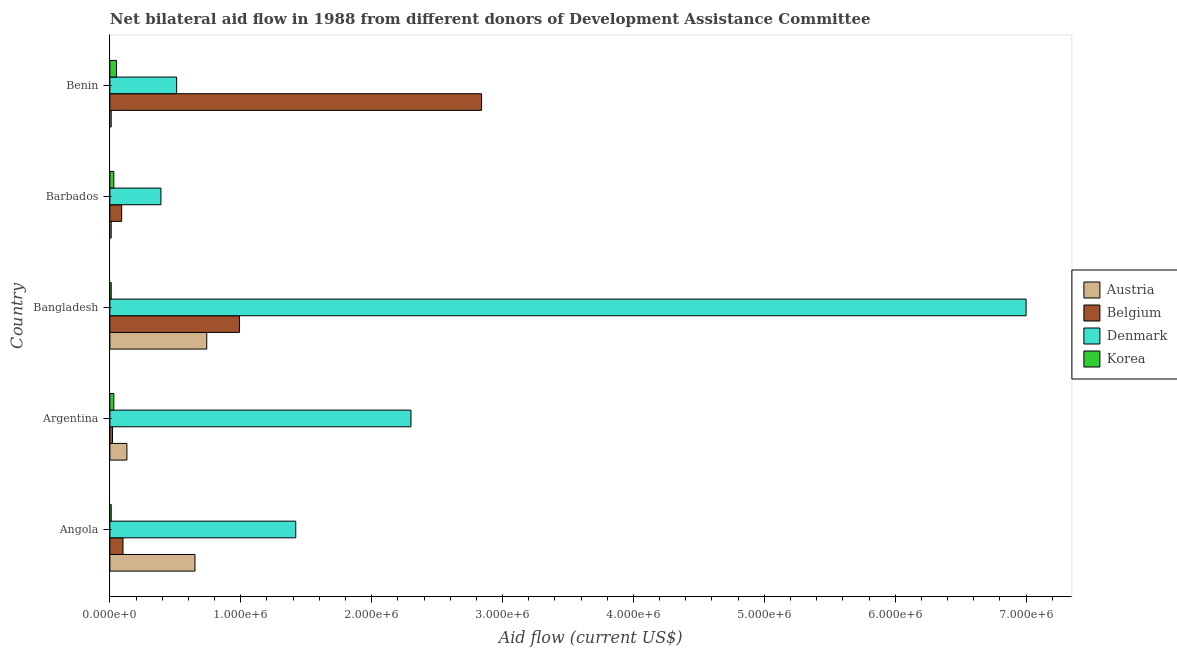Are the number of bars per tick equal to the number of legend labels?
Give a very brief answer. Yes. How many bars are there on the 5th tick from the top?
Give a very brief answer. 4. What is the label of the 2nd group of bars from the top?
Give a very brief answer. Barbados. What is the amount of aid given by korea in Bangladesh?
Offer a very short reply. 10000. Across all countries, what is the maximum amount of aid given by austria?
Your answer should be very brief. 7.40e+05. Across all countries, what is the minimum amount of aid given by austria?
Make the answer very short. 10000. In which country was the amount of aid given by denmark minimum?
Your answer should be very brief. Barbados. What is the total amount of aid given by denmark in the graph?
Ensure brevity in your answer.  1.16e+07. What is the difference between the amount of aid given by korea in Bangladesh and that in Barbados?
Offer a very short reply. -2.00e+04. What is the average amount of aid given by korea per country?
Ensure brevity in your answer.  2.60e+04. What is the difference between the amount of aid given by korea and amount of aid given by denmark in Angola?
Make the answer very short. -1.41e+06. In how many countries, is the amount of aid given by austria greater than 5600000 US$?
Make the answer very short. 0. What is the ratio of the amount of aid given by denmark in Angola to that in Argentina?
Offer a terse response. 0.62. What is the difference between the highest and the lowest amount of aid given by denmark?
Make the answer very short. 6.61e+06. Is the sum of the amount of aid given by austria in Argentina and Barbados greater than the maximum amount of aid given by korea across all countries?
Keep it short and to the point. Yes. What does the 1st bar from the top in Barbados represents?
Your answer should be very brief. Korea. What does the 3rd bar from the bottom in Benin represents?
Offer a terse response. Denmark. Are the values on the major ticks of X-axis written in scientific E-notation?
Your answer should be compact. Yes. Does the graph contain any zero values?
Offer a terse response. No. How many legend labels are there?
Offer a terse response. 4. What is the title of the graph?
Provide a succinct answer. Net bilateral aid flow in 1988 from different donors of Development Assistance Committee. What is the label or title of the X-axis?
Your response must be concise. Aid flow (current US$). What is the Aid flow (current US$) in Austria in Angola?
Your answer should be very brief. 6.50e+05. What is the Aid flow (current US$) in Denmark in Angola?
Ensure brevity in your answer.  1.42e+06. What is the Aid flow (current US$) in Denmark in Argentina?
Provide a succinct answer. 2.30e+06. What is the Aid flow (current US$) in Austria in Bangladesh?
Provide a succinct answer. 7.40e+05. What is the Aid flow (current US$) of Belgium in Bangladesh?
Your answer should be very brief. 9.90e+05. What is the Aid flow (current US$) of Belgium in Barbados?
Make the answer very short. 9.00e+04. What is the Aid flow (current US$) of Austria in Benin?
Your answer should be compact. 10000. What is the Aid flow (current US$) of Belgium in Benin?
Provide a short and direct response. 2.84e+06. What is the Aid flow (current US$) of Denmark in Benin?
Provide a succinct answer. 5.10e+05. Across all countries, what is the maximum Aid flow (current US$) of Austria?
Your response must be concise. 7.40e+05. Across all countries, what is the maximum Aid flow (current US$) in Belgium?
Your response must be concise. 2.84e+06. Across all countries, what is the minimum Aid flow (current US$) of Belgium?
Offer a terse response. 2.00e+04. Across all countries, what is the minimum Aid flow (current US$) in Denmark?
Offer a very short reply. 3.90e+05. What is the total Aid flow (current US$) of Austria in the graph?
Provide a short and direct response. 1.54e+06. What is the total Aid flow (current US$) in Belgium in the graph?
Ensure brevity in your answer.  4.04e+06. What is the total Aid flow (current US$) in Denmark in the graph?
Keep it short and to the point. 1.16e+07. What is the difference between the Aid flow (current US$) of Austria in Angola and that in Argentina?
Ensure brevity in your answer.  5.20e+05. What is the difference between the Aid flow (current US$) of Denmark in Angola and that in Argentina?
Make the answer very short. -8.80e+05. What is the difference between the Aid flow (current US$) of Korea in Angola and that in Argentina?
Your response must be concise. -2.00e+04. What is the difference between the Aid flow (current US$) in Austria in Angola and that in Bangladesh?
Your response must be concise. -9.00e+04. What is the difference between the Aid flow (current US$) in Belgium in Angola and that in Bangladesh?
Keep it short and to the point. -8.90e+05. What is the difference between the Aid flow (current US$) of Denmark in Angola and that in Bangladesh?
Offer a very short reply. -5.58e+06. What is the difference between the Aid flow (current US$) in Korea in Angola and that in Bangladesh?
Offer a very short reply. 0. What is the difference between the Aid flow (current US$) in Austria in Angola and that in Barbados?
Your answer should be compact. 6.40e+05. What is the difference between the Aid flow (current US$) of Denmark in Angola and that in Barbados?
Your answer should be very brief. 1.03e+06. What is the difference between the Aid flow (current US$) in Austria in Angola and that in Benin?
Give a very brief answer. 6.40e+05. What is the difference between the Aid flow (current US$) of Belgium in Angola and that in Benin?
Make the answer very short. -2.74e+06. What is the difference between the Aid flow (current US$) in Denmark in Angola and that in Benin?
Your answer should be very brief. 9.10e+05. What is the difference between the Aid flow (current US$) in Austria in Argentina and that in Bangladesh?
Keep it short and to the point. -6.10e+05. What is the difference between the Aid flow (current US$) in Belgium in Argentina and that in Bangladesh?
Your answer should be compact. -9.70e+05. What is the difference between the Aid flow (current US$) of Denmark in Argentina and that in Bangladesh?
Provide a succinct answer. -4.70e+06. What is the difference between the Aid flow (current US$) in Belgium in Argentina and that in Barbados?
Offer a very short reply. -7.00e+04. What is the difference between the Aid flow (current US$) of Denmark in Argentina and that in Barbados?
Make the answer very short. 1.91e+06. What is the difference between the Aid flow (current US$) in Austria in Argentina and that in Benin?
Provide a succinct answer. 1.20e+05. What is the difference between the Aid flow (current US$) of Belgium in Argentina and that in Benin?
Give a very brief answer. -2.82e+06. What is the difference between the Aid flow (current US$) in Denmark in Argentina and that in Benin?
Make the answer very short. 1.79e+06. What is the difference between the Aid flow (current US$) in Austria in Bangladesh and that in Barbados?
Your response must be concise. 7.30e+05. What is the difference between the Aid flow (current US$) in Belgium in Bangladesh and that in Barbados?
Your answer should be compact. 9.00e+05. What is the difference between the Aid flow (current US$) of Denmark in Bangladesh and that in Barbados?
Your answer should be very brief. 6.61e+06. What is the difference between the Aid flow (current US$) in Korea in Bangladesh and that in Barbados?
Give a very brief answer. -2.00e+04. What is the difference between the Aid flow (current US$) in Austria in Bangladesh and that in Benin?
Offer a terse response. 7.30e+05. What is the difference between the Aid flow (current US$) of Belgium in Bangladesh and that in Benin?
Provide a short and direct response. -1.85e+06. What is the difference between the Aid flow (current US$) of Denmark in Bangladesh and that in Benin?
Give a very brief answer. 6.49e+06. What is the difference between the Aid flow (current US$) in Austria in Barbados and that in Benin?
Give a very brief answer. 0. What is the difference between the Aid flow (current US$) in Belgium in Barbados and that in Benin?
Offer a very short reply. -2.75e+06. What is the difference between the Aid flow (current US$) of Denmark in Barbados and that in Benin?
Offer a very short reply. -1.20e+05. What is the difference between the Aid flow (current US$) in Austria in Angola and the Aid flow (current US$) in Belgium in Argentina?
Offer a very short reply. 6.30e+05. What is the difference between the Aid flow (current US$) of Austria in Angola and the Aid flow (current US$) of Denmark in Argentina?
Give a very brief answer. -1.65e+06. What is the difference between the Aid flow (current US$) in Austria in Angola and the Aid flow (current US$) in Korea in Argentina?
Your response must be concise. 6.20e+05. What is the difference between the Aid flow (current US$) in Belgium in Angola and the Aid flow (current US$) in Denmark in Argentina?
Ensure brevity in your answer.  -2.20e+06. What is the difference between the Aid flow (current US$) of Denmark in Angola and the Aid flow (current US$) of Korea in Argentina?
Give a very brief answer. 1.39e+06. What is the difference between the Aid flow (current US$) in Austria in Angola and the Aid flow (current US$) in Belgium in Bangladesh?
Make the answer very short. -3.40e+05. What is the difference between the Aid flow (current US$) in Austria in Angola and the Aid flow (current US$) in Denmark in Bangladesh?
Your answer should be very brief. -6.35e+06. What is the difference between the Aid flow (current US$) of Austria in Angola and the Aid flow (current US$) of Korea in Bangladesh?
Offer a very short reply. 6.40e+05. What is the difference between the Aid flow (current US$) of Belgium in Angola and the Aid flow (current US$) of Denmark in Bangladesh?
Offer a very short reply. -6.90e+06. What is the difference between the Aid flow (current US$) of Belgium in Angola and the Aid flow (current US$) of Korea in Bangladesh?
Your answer should be compact. 9.00e+04. What is the difference between the Aid flow (current US$) of Denmark in Angola and the Aid flow (current US$) of Korea in Bangladesh?
Your answer should be compact. 1.41e+06. What is the difference between the Aid flow (current US$) of Austria in Angola and the Aid flow (current US$) of Belgium in Barbados?
Provide a short and direct response. 5.60e+05. What is the difference between the Aid flow (current US$) of Austria in Angola and the Aid flow (current US$) of Korea in Barbados?
Your answer should be compact. 6.20e+05. What is the difference between the Aid flow (current US$) in Belgium in Angola and the Aid flow (current US$) in Korea in Barbados?
Provide a succinct answer. 7.00e+04. What is the difference between the Aid flow (current US$) of Denmark in Angola and the Aid flow (current US$) of Korea in Barbados?
Your answer should be very brief. 1.39e+06. What is the difference between the Aid flow (current US$) in Austria in Angola and the Aid flow (current US$) in Belgium in Benin?
Your response must be concise. -2.19e+06. What is the difference between the Aid flow (current US$) of Austria in Angola and the Aid flow (current US$) of Korea in Benin?
Provide a short and direct response. 6.00e+05. What is the difference between the Aid flow (current US$) of Belgium in Angola and the Aid flow (current US$) of Denmark in Benin?
Your answer should be compact. -4.10e+05. What is the difference between the Aid flow (current US$) of Belgium in Angola and the Aid flow (current US$) of Korea in Benin?
Offer a very short reply. 5.00e+04. What is the difference between the Aid flow (current US$) in Denmark in Angola and the Aid flow (current US$) in Korea in Benin?
Keep it short and to the point. 1.37e+06. What is the difference between the Aid flow (current US$) in Austria in Argentina and the Aid flow (current US$) in Belgium in Bangladesh?
Offer a terse response. -8.60e+05. What is the difference between the Aid flow (current US$) of Austria in Argentina and the Aid flow (current US$) of Denmark in Bangladesh?
Your answer should be compact. -6.87e+06. What is the difference between the Aid flow (current US$) in Austria in Argentina and the Aid flow (current US$) in Korea in Bangladesh?
Your response must be concise. 1.20e+05. What is the difference between the Aid flow (current US$) in Belgium in Argentina and the Aid flow (current US$) in Denmark in Bangladesh?
Your answer should be very brief. -6.98e+06. What is the difference between the Aid flow (current US$) of Denmark in Argentina and the Aid flow (current US$) of Korea in Bangladesh?
Provide a short and direct response. 2.29e+06. What is the difference between the Aid flow (current US$) in Austria in Argentina and the Aid flow (current US$) in Belgium in Barbados?
Provide a short and direct response. 4.00e+04. What is the difference between the Aid flow (current US$) of Austria in Argentina and the Aid flow (current US$) of Denmark in Barbados?
Your response must be concise. -2.60e+05. What is the difference between the Aid flow (current US$) in Belgium in Argentina and the Aid flow (current US$) in Denmark in Barbados?
Your answer should be very brief. -3.70e+05. What is the difference between the Aid flow (current US$) of Denmark in Argentina and the Aid flow (current US$) of Korea in Barbados?
Your response must be concise. 2.27e+06. What is the difference between the Aid flow (current US$) in Austria in Argentina and the Aid flow (current US$) in Belgium in Benin?
Ensure brevity in your answer.  -2.71e+06. What is the difference between the Aid flow (current US$) of Austria in Argentina and the Aid flow (current US$) of Denmark in Benin?
Ensure brevity in your answer.  -3.80e+05. What is the difference between the Aid flow (current US$) in Belgium in Argentina and the Aid flow (current US$) in Denmark in Benin?
Keep it short and to the point. -4.90e+05. What is the difference between the Aid flow (current US$) in Denmark in Argentina and the Aid flow (current US$) in Korea in Benin?
Provide a short and direct response. 2.25e+06. What is the difference between the Aid flow (current US$) of Austria in Bangladesh and the Aid flow (current US$) of Belgium in Barbados?
Give a very brief answer. 6.50e+05. What is the difference between the Aid flow (current US$) in Austria in Bangladesh and the Aid flow (current US$) in Korea in Barbados?
Make the answer very short. 7.10e+05. What is the difference between the Aid flow (current US$) of Belgium in Bangladesh and the Aid flow (current US$) of Korea in Barbados?
Your answer should be very brief. 9.60e+05. What is the difference between the Aid flow (current US$) of Denmark in Bangladesh and the Aid flow (current US$) of Korea in Barbados?
Your answer should be compact. 6.97e+06. What is the difference between the Aid flow (current US$) in Austria in Bangladesh and the Aid flow (current US$) in Belgium in Benin?
Your response must be concise. -2.10e+06. What is the difference between the Aid flow (current US$) in Austria in Bangladesh and the Aid flow (current US$) in Korea in Benin?
Your answer should be very brief. 6.90e+05. What is the difference between the Aid flow (current US$) of Belgium in Bangladesh and the Aid flow (current US$) of Denmark in Benin?
Make the answer very short. 4.80e+05. What is the difference between the Aid flow (current US$) of Belgium in Bangladesh and the Aid flow (current US$) of Korea in Benin?
Your answer should be compact. 9.40e+05. What is the difference between the Aid flow (current US$) in Denmark in Bangladesh and the Aid flow (current US$) in Korea in Benin?
Provide a succinct answer. 6.95e+06. What is the difference between the Aid flow (current US$) in Austria in Barbados and the Aid flow (current US$) in Belgium in Benin?
Offer a very short reply. -2.83e+06. What is the difference between the Aid flow (current US$) in Austria in Barbados and the Aid flow (current US$) in Denmark in Benin?
Your answer should be compact. -5.00e+05. What is the difference between the Aid flow (current US$) of Belgium in Barbados and the Aid flow (current US$) of Denmark in Benin?
Ensure brevity in your answer.  -4.20e+05. What is the difference between the Aid flow (current US$) of Denmark in Barbados and the Aid flow (current US$) of Korea in Benin?
Provide a short and direct response. 3.40e+05. What is the average Aid flow (current US$) in Austria per country?
Your response must be concise. 3.08e+05. What is the average Aid flow (current US$) of Belgium per country?
Offer a terse response. 8.08e+05. What is the average Aid flow (current US$) in Denmark per country?
Ensure brevity in your answer.  2.32e+06. What is the average Aid flow (current US$) of Korea per country?
Ensure brevity in your answer.  2.60e+04. What is the difference between the Aid flow (current US$) of Austria and Aid flow (current US$) of Belgium in Angola?
Your response must be concise. 5.50e+05. What is the difference between the Aid flow (current US$) in Austria and Aid flow (current US$) in Denmark in Angola?
Provide a succinct answer. -7.70e+05. What is the difference between the Aid flow (current US$) in Austria and Aid flow (current US$) in Korea in Angola?
Provide a succinct answer. 6.40e+05. What is the difference between the Aid flow (current US$) of Belgium and Aid flow (current US$) of Denmark in Angola?
Offer a terse response. -1.32e+06. What is the difference between the Aid flow (current US$) in Belgium and Aid flow (current US$) in Korea in Angola?
Your response must be concise. 9.00e+04. What is the difference between the Aid flow (current US$) in Denmark and Aid flow (current US$) in Korea in Angola?
Offer a very short reply. 1.41e+06. What is the difference between the Aid flow (current US$) of Austria and Aid flow (current US$) of Belgium in Argentina?
Your answer should be compact. 1.10e+05. What is the difference between the Aid flow (current US$) in Austria and Aid flow (current US$) in Denmark in Argentina?
Keep it short and to the point. -2.17e+06. What is the difference between the Aid flow (current US$) of Austria and Aid flow (current US$) of Korea in Argentina?
Make the answer very short. 1.00e+05. What is the difference between the Aid flow (current US$) of Belgium and Aid flow (current US$) of Denmark in Argentina?
Your response must be concise. -2.28e+06. What is the difference between the Aid flow (current US$) in Denmark and Aid flow (current US$) in Korea in Argentina?
Offer a very short reply. 2.27e+06. What is the difference between the Aid flow (current US$) of Austria and Aid flow (current US$) of Belgium in Bangladesh?
Your answer should be very brief. -2.50e+05. What is the difference between the Aid flow (current US$) in Austria and Aid flow (current US$) in Denmark in Bangladesh?
Provide a succinct answer. -6.26e+06. What is the difference between the Aid flow (current US$) of Austria and Aid flow (current US$) of Korea in Bangladesh?
Offer a terse response. 7.30e+05. What is the difference between the Aid flow (current US$) in Belgium and Aid flow (current US$) in Denmark in Bangladesh?
Offer a very short reply. -6.01e+06. What is the difference between the Aid flow (current US$) of Belgium and Aid flow (current US$) of Korea in Bangladesh?
Provide a succinct answer. 9.80e+05. What is the difference between the Aid flow (current US$) of Denmark and Aid flow (current US$) of Korea in Bangladesh?
Offer a very short reply. 6.99e+06. What is the difference between the Aid flow (current US$) of Austria and Aid flow (current US$) of Belgium in Barbados?
Make the answer very short. -8.00e+04. What is the difference between the Aid flow (current US$) of Austria and Aid flow (current US$) of Denmark in Barbados?
Provide a succinct answer. -3.80e+05. What is the difference between the Aid flow (current US$) in Belgium and Aid flow (current US$) in Denmark in Barbados?
Keep it short and to the point. -3.00e+05. What is the difference between the Aid flow (current US$) in Austria and Aid flow (current US$) in Belgium in Benin?
Keep it short and to the point. -2.83e+06. What is the difference between the Aid flow (current US$) in Austria and Aid flow (current US$) in Denmark in Benin?
Your answer should be very brief. -5.00e+05. What is the difference between the Aid flow (current US$) of Austria and Aid flow (current US$) of Korea in Benin?
Your answer should be very brief. -4.00e+04. What is the difference between the Aid flow (current US$) in Belgium and Aid flow (current US$) in Denmark in Benin?
Your answer should be very brief. 2.33e+06. What is the difference between the Aid flow (current US$) in Belgium and Aid flow (current US$) in Korea in Benin?
Your answer should be compact. 2.79e+06. What is the difference between the Aid flow (current US$) of Denmark and Aid flow (current US$) of Korea in Benin?
Your answer should be very brief. 4.60e+05. What is the ratio of the Aid flow (current US$) of Austria in Angola to that in Argentina?
Make the answer very short. 5. What is the ratio of the Aid flow (current US$) of Belgium in Angola to that in Argentina?
Give a very brief answer. 5. What is the ratio of the Aid flow (current US$) in Denmark in Angola to that in Argentina?
Provide a short and direct response. 0.62. What is the ratio of the Aid flow (current US$) in Korea in Angola to that in Argentina?
Provide a succinct answer. 0.33. What is the ratio of the Aid flow (current US$) in Austria in Angola to that in Bangladesh?
Offer a terse response. 0.88. What is the ratio of the Aid flow (current US$) of Belgium in Angola to that in Bangladesh?
Your response must be concise. 0.1. What is the ratio of the Aid flow (current US$) of Denmark in Angola to that in Bangladesh?
Provide a short and direct response. 0.2. What is the ratio of the Aid flow (current US$) of Austria in Angola to that in Barbados?
Make the answer very short. 65. What is the ratio of the Aid flow (current US$) of Denmark in Angola to that in Barbados?
Keep it short and to the point. 3.64. What is the ratio of the Aid flow (current US$) in Korea in Angola to that in Barbados?
Offer a very short reply. 0.33. What is the ratio of the Aid flow (current US$) of Belgium in Angola to that in Benin?
Ensure brevity in your answer.  0.04. What is the ratio of the Aid flow (current US$) in Denmark in Angola to that in Benin?
Your answer should be compact. 2.78. What is the ratio of the Aid flow (current US$) in Korea in Angola to that in Benin?
Give a very brief answer. 0.2. What is the ratio of the Aid flow (current US$) of Austria in Argentina to that in Bangladesh?
Make the answer very short. 0.18. What is the ratio of the Aid flow (current US$) in Belgium in Argentina to that in Bangladesh?
Provide a short and direct response. 0.02. What is the ratio of the Aid flow (current US$) of Denmark in Argentina to that in Bangladesh?
Make the answer very short. 0.33. What is the ratio of the Aid flow (current US$) of Austria in Argentina to that in Barbados?
Provide a short and direct response. 13. What is the ratio of the Aid flow (current US$) of Belgium in Argentina to that in Barbados?
Make the answer very short. 0.22. What is the ratio of the Aid flow (current US$) of Denmark in Argentina to that in Barbados?
Your answer should be very brief. 5.9. What is the ratio of the Aid flow (current US$) of Korea in Argentina to that in Barbados?
Offer a terse response. 1. What is the ratio of the Aid flow (current US$) in Austria in Argentina to that in Benin?
Offer a very short reply. 13. What is the ratio of the Aid flow (current US$) in Belgium in Argentina to that in Benin?
Offer a terse response. 0.01. What is the ratio of the Aid flow (current US$) of Denmark in Argentina to that in Benin?
Your answer should be compact. 4.51. What is the ratio of the Aid flow (current US$) of Denmark in Bangladesh to that in Barbados?
Ensure brevity in your answer.  17.95. What is the ratio of the Aid flow (current US$) of Austria in Bangladesh to that in Benin?
Ensure brevity in your answer.  74. What is the ratio of the Aid flow (current US$) of Belgium in Bangladesh to that in Benin?
Give a very brief answer. 0.35. What is the ratio of the Aid flow (current US$) of Denmark in Bangladesh to that in Benin?
Ensure brevity in your answer.  13.73. What is the ratio of the Aid flow (current US$) in Austria in Barbados to that in Benin?
Ensure brevity in your answer.  1. What is the ratio of the Aid flow (current US$) of Belgium in Barbados to that in Benin?
Keep it short and to the point. 0.03. What is the ratio of the Aid flow (current US$) of Denmark in Barbados to that in Benin?
Your answer should be compact. 0.76. What is the difference between the highest and the second highest Aid flow (current US$) of Belgium?
Keep it short and to the point. 1.85e+06. What is the difference between the highest and the second highest Aid flow (current US$) in Denmark?
Your answer should be compact. 4.70e+06. What is the difference between the highest and the lowest Aid flow (current US$) of Austria?
Provide a short and direct response. 7.30e+05. What is the difference between the highest and the lowest Aid flow (current US$) of Belgium?
Provide a short and direct response. 2.82e+06. What is the difference between the highest and the lowest Aid flow (current US$) in Denmark?
Your answer should be very brief. 6.61e+06. What is the difference between the highest and the lowest Aid flow (current US$) of Korea?
Give a very brief answer. 4.00e+04. 